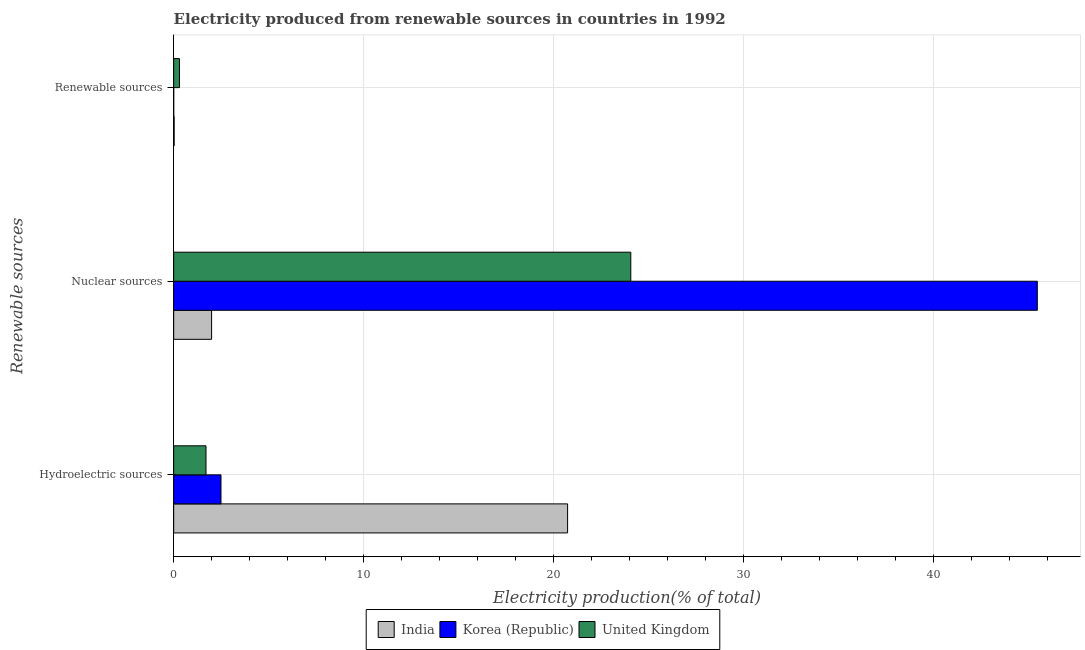How many groups of bars are there?
Offer a very short reply. 3. Are the number of bars on each tick of the Y-axis equal?
Provide a short and direct response. Yes. What is the label of the 2nd group of bars from the top?
Offer a very short reply. Nuclear sources. What is the percentage of electricity produced by nuclear sources in Korea (Republic)?
Make the answer very short. 45.44. Across all countries, what is the maximum percentage of electricity produced by nuclear sources?
Your response must be concise. 45.44. Across all countries, what is the minimum percentage of electricity produced by hydroelectric sources?
Your response must be concise. 1.7. What is the total percentage of electricity produced by renewable sources in the graph?
Make the answer very short. 0.33. What is the difference between the percentage of electricity produced by hydroelectric sources in India and that in United Kingdom?
Provide a short and direct response. 19.03. What is the difference between the percentage of electricity produced by hydroelectric sources in India and the percentage of electricity produced by nuclear sources in United Kingdom?
Your response must be concise. -3.32. What is the average percentage of electricity produced by nuclear sources per country?
Provide a succinct answer. 23.83. What is the difference between the percentage of electricity produced by renewable sources and percentage of electricity produced by nuclear sources in United Kingdom?
Offer a terse response. -23.75. What is the ratio of the percentage of electricity produced by renewable sources in India to that in United Kingdom?
Your answer should be very brief. 0.09. Is the difference between the percentage of electricity produced by hydroelectric sources in Korea (Republic) and India greater than the difference between the percentage of electricity produced by nuclear sources in Korea (Republic) and India?
Give a very brief answer. No. What is the difference between the highest and the second highest percentage of electricity produced by hydroelectric sources?
Ensure brevity in your answer.  18.24. What is the difference between the highest and the lowest percentage of electricity produced by hydroelectric sources?
Provide a succinct answer. 19.03. Is the sum of the percentage of electricity produced by nuclear sources in United Kingdom and India greater than the maximum percentage of electricity produced by renewable sources across all countries?
Provide a succinct answer. Yes. Are all the bars in the graph horizontal?
Keep it short and to the point. Yes. What is the difference between two consecutive major ticks on the X-axis?
Offer a very short reply. 10. Does the graph contain grids?
Your answer should be very brief. Yes. Where does the legend appear in the graph?
Keep it short and to the point. Bottom center. How many legend labels are there?
Your answer should be compact. 3. What is the title of the graph?
Give a very brief answer. Electricity produced from renewable sources in countries in 1992. What is the label or title of the Y-axis?
Keep it short and to the point. Renewable sources. What is the Electricity production(% of total) in India in Hydroelectric sources?
Offer a terse response. 20.73. What is the Electricity production(% of total) in Korea (Republic) in Hydroelectric sources?
Your response must be concise. 2.49. What is the Electricity production(% of total) in United Kingdom in Hydroelectric sources?
Provide a succinct answer. 1.7. What is the Electricity production(% of total) in India in Nuclear sources?
Offer a very short reply. 1.99. What is the Electricity production(% of total) of Korea (Republic) in Nuclear sources?
Give a very brief answer. 45.44. What is the Electricity production(% of total) of United Kingdom in Nuclear sources?
Make the answer very short. 24.05. What is the Electricity production(% of total) in India in Renewable sources?
Your answer should be very brief. 0.03. What is the Electricity production(% of total) in Korea (Republic) in Renewable sources?
Your answer should be compact. 0. What is the Electricity production(% of total) in United Kingdom in Renewable sources?
Provide a succinct answer. 0.3. Across all Renewable sources, what is the maximum Electricity production(% of total) of India?
Your response must be concise. 20.73. Across all Renewable sources, what is the maximum Electricity production(% of total) of Korea (Republic)?
Your answer should be compact. 45.44. Across all Renewable sources, what is the maximum Electricity production(% of total) in United Kingdom?
Offer a very short reply. 24.05. Across all Renewable sources, what is the minimum Electricity production(% of total) of India?
Provide a short and direct response. 0.03. Across all Renewable sources, what is the minimum Electricity production(% of total) of Korea (Republic)?
Keep it short and to the point. 0. Across all Renewable sources, what is the minimum Electricity production(% of total) in United Kingdom?
Provide a short and direct response. 0.3. What is the total Electricity production(% of total) of India in the graph?
Keep it short and to the point. 22.75. What is the total Electricity production(% of total) in Korea (Republic) in the graph?
Give a very brief answer. 47.93. What is the total Electricity production(% of total) in United Kingdom in the graph?
Provide a succinct answer. 26.06. What is the difference between the Electricity production(% of total) in India in Hydroelectric sources and that in Nuclear sources?
Your response must be concise. 18.73. What is the difference between the Electricity production(% of total) in Korea (Republic) in Hydroelectric sources and that in Nuclear sources?
Offer a very short reply. -42.95. What is the difference between the Electricity production(% of total) in United Kingdom in Hydroelectric sources and that in Nuclear sources?
Your answer should be compact. -22.35. What is the difference between the Electricity production(% of total) of India in Hydroelectric sources and that in Renewable sources?
Your answer should be very brief. 20.7. What is the difference between the Electricity production(% of total) in Korea (Republic) in Hydroelectric sources and that in Renewable sources?
Your response must be concise. 2.49. What is the difference between the Electricity production(% of total) of United Kingdom in Hydroelectric sources and that in Renewable sources?
Provide a succinct answer. 1.4. What is the difference between the Electricity production(% of total) of India in Nuclear sources and that in Renewable sources?
Give a very brief answer. 1.97. What is the difference between the Electricity production(% of total) of Korea (Republic) in Nuclear sources and that in Renewable sources?
Keep it short and to the point. 45.44. What is the difference between the Electricity production(% of total) of United Kingdom in Nuclear sources and that in Renewable sources?
Offer a terse response. 23.75. What is the difference between the Electricity production(% of total) of India in Hydroelectric sources and the Electricity production(% of total) of Korea (Republic) in Nuclear sources?
Your answer should be very brief. -24.71. What is the difference between the Electricity production(% of total) in India in Hydroelectric sources and the Electricity production(% of total) in United Kingdom in Nuclear sources?
Provide a short and direct response. -3.32. What is the difference between the Electricity production(% of total) of Korea (Republic) in Hydroelectric sources and the Electricity production(% of total) of United Kingdom in Nuclear sources?
Keep it short and to the point. -21.56. What is the difference between the Electricity production(% of total) of India in Hydroelectric sources and the Electricity production(% of total) of Korea (Republic) in Renewable sources?
Keep it short and to the point. 20.72. What is the difference between the Electricity production(% of total) of India in Hydroelectric sources and the Electricity production(% of total) of United Kingdom in Renewable sources?
Ensure brevity in your answer.  20.42. What is the difference between the Electricity production(% of total) in Korea (Republic) in Hydroelectric sources and the Electricity production(% of total) in United Kingdom in Renewable sources?
Keep it short and to the point. 2.18. What is the difference between the Electricity production(% of total) in India in Nuclear sources and the Electricity production(% of total) in Korea (Republic) in Renewable sources?
Provide a succinct answer. 1.99. What is the difference between the Electricity production(% of total) of India in Nuclear sources and the Electricity production(% of total) of United Kingdom in Renewable sources?
Your answer should be very brief. 1.69. What is the difference between the Electricity production(% of total) in Korea (Republic) in Nuclear sources and the Electricity production(% of total) in United Kingdom in Renewable sources?
Your answer should be very brief. 45.14. What is the average Electricity production(% of total) in India per Renewable sources?
Offer a very short reply. 7.58. What is the average Electricity production(% of total) in Korea (Republic) per Renewable sources?
Keep it short and to the point. 15.98. What is the average Electricity production(% of total) in United Kingdom per Renewable sources?
Make the answer very short. 8.69. What is the difference between the Electricity production(% of total) of India and Electricity production(% of total) of Korea (Republic) in Hydroelectric sources?
Your answer should be very brief. 18.24. What is the difference between the Electricity production(% of total) of India and Electricity production(% of total) of United Kingdom in Hydroelectric sources?
Offer a terse response. 19.03. What is the difference between the Electricity production(% of total) of Korea (Republic) and Electricity production(% of total) of United Kingdom in Hydroelectric sources?
Your response must be concise. 0.79. What is the difference between the Electricity production(% of total) in India and Electricity production(% of total) in Korea (Republic) in Nuclear sources?
Your answer should be compact. -43.45. What is the difference between the Electricity production(% of total) of India and Electricity production(% of total) of United Kingdom in Nuclear sources?
Your response must be concise. -22.06. What is the difference between the Electricity production(% of total) in Korea (Republic) and Electricity production(% of total) in United Kingdom in Nuclear sources?
Keep it short and to the point. 21.39. What is the difference between the Electricity production(% of total) of India and Electricity production(% of total) of Korea (Republic) in Renewable sources?
Ensure brevity in your answer.  0.02. What is the difference between the Electricity production(% of total) in India and Electricity production(% of total) in United Kingdom in Renewable sources?
Your answer should be compact. -0.28. What is the difference between the Electricity production(% of total) of Korea (Republic) and Electricity production(% of total) of United Kingdom in Renewable sources?
Keep it short and to the point. -0.3. What is the ratio of the Electricity production(% of total) in India in Hydroelectric sources to that in Nuclear sources?
Make the answer very short. 10.39. What is the ratio of the Electricity production(% of total) in Korea (Republic) in Hydroelectric sources to that in Nuclear sources?
Keep it short and to the point. 0.05. What is the ratio of the Electricity production(% of total) in United Kingdom in Hydroelectric sources to that in Nuclear sources?
Your answer should be compact. 0.07. What is the ratio of the Electricity production(% of total) of India in Hydroelectric sources to that in Renewable sources?
Your answer should be very brief. 794.16. What is the ratio of the Electricity production(% of total) of Korea (Republic) in Hydroelectric sources to that in Renewable sources?
Make the answer very short. 1548.5. What is the ratio of the Electricity production(% of total) in United Kingdom in Hydroelectric sources to that in Renewable sources?
Your response must be concise. 5.58. What is the ratio of the Electricity production(% of total) of India in Nuclear sources to that in Renewable sources?
Your answer should be compact. 76.43. What is the ratio of the Electricity production(% of total) in Korea (Republic) in Nuclear sources to that in Renewable sources?
Give a very brief answer. 2.83e+04. What is the ratio of the Electricity production(% of total) in United Kingdom in Nuclear sources to that in Renewable sources?
Provide a short and direct response. 78.86. What is the difference between the highest and the second highest Electricity production(% of total) in India?
Provide a succinct answer. 18.73. What is the difference between the highest and the second highest Electricity production(% of total) in Korea (Republic)?
Provide a short and direct response. 42.95. What is the difference between the highest and the second highest Electricity production(% of total) in United Kingdom?
Ensure brevity in your answer.  22.35. What is the difference between the highest and the lowest Electricity production(% of total) in India?
Make the answer very short. 20.7. What is the difference between the highest and the lowest Electricity production(% of total) of Korea (Republic)?
Keep it short and to the point. 45.44. What is the difference between the highest and the lowest Electricity production(% of total) in United Kingdom?
Give a very brief answer. 23.75. 